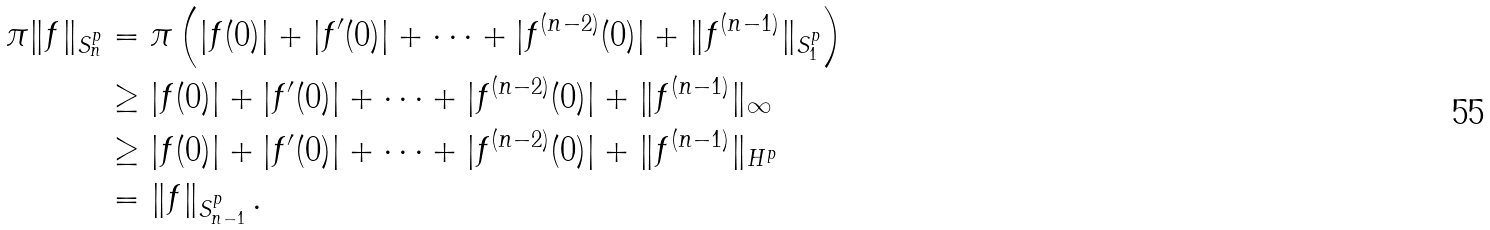<formula> <loc_0><loc_0><loc_500><loc_500>\pi \| f \| _ { S _ { n } ^ { p } } & = \pi \left ( | f ( 0 ) | + | f ^ { \prime } ( 0 ) | + \cdots + | f ^ { ( n - 2 ) } ( 0 ) | + \| f ^ { ( n - 1 ) } \| _ { S _ { 1 } ^ { p } } \right ) \\ & \geq | f ( 0 ) | + | f ^ { \prime } ( 0 ) | + \cdots + | f ^ { ( n - 2 ) } ( 0 ) | + \| f ^ { ( n - 1 ) } \| _ { \infty } \\ & \geq | f ( 0 ) | + | f ^ { \prime } ( 0 ) | + \cdots + | f ^ { ( n - 2 ) } ( 0 ) | + \| f ^ { ( n - 1 ) } \| _ { H ^ { p } } \\ & = \| f \| _ { S _ { n - 1 } ^ { p } } \, .</formula> 